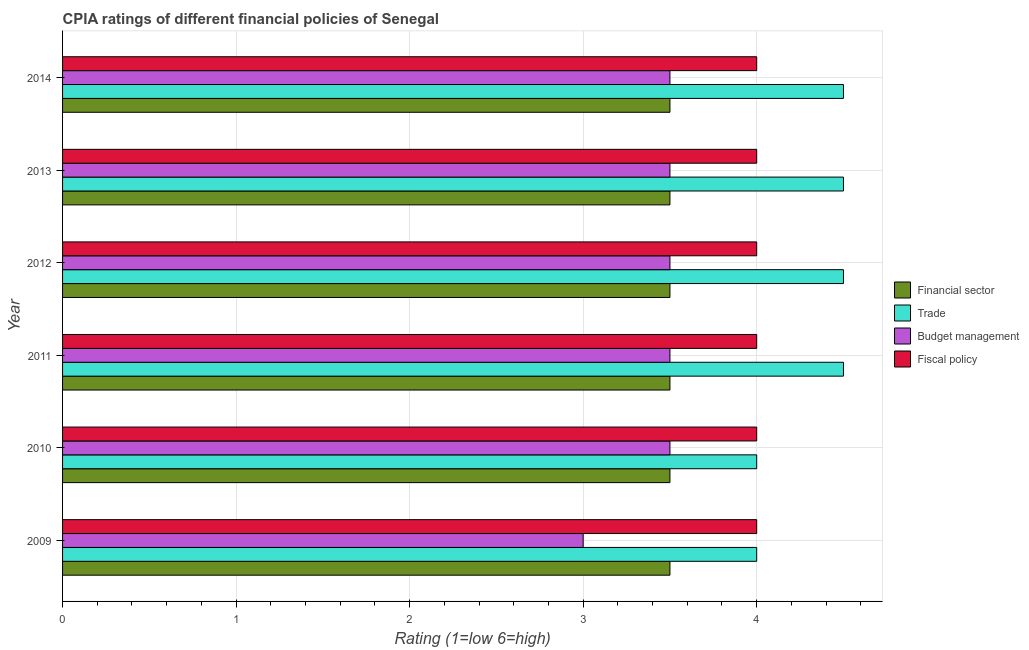How many different coloured bars are there?
Give a very brief answer. 4. How many groups of bars are there?
Your answer should be compact. 6. How many bars are there on the 5th tick from the top?
Provide a short and direct response. 4. How many bars are there on the 2nd tick from the bottom?
Your response must be concise. 4. What is the label of the 5th group of bars from the top?
Offer a very short reply. 2010. In how many cases, is the number of bars for a given year not equal to the number of legend labels?
Your answer should be very brief. 0. In which year was the cpia rating of financial sector maximum?
Make the answer very short. 2009. In which year was the cpia rating of budget management minimum?
Keep it short and to the point. 2009. What is the difference between the cpia rating of fiscal policy in 2011 and that in 2013?
Provide a succinct answer. 0. What is the difference between the cpia rating of budget management in 2012 and the cpia rating of fiscal policy in 2011?
Your answer should be compact. -0.5. What is the average cpia rating of budget management per year?
Offer a very short reply. 3.42. In the year 2011, what is the difference between the cpia rating of fiscal policy and cpia rating of budget management?
Provide a short and direct response. 0.5. What is the ratio of the cpia rating of financial sector in 2009 to that in 2013?
Provide a short and direct response. 1. Is the difference between the cpia rating of trade in 2012 and 2014 greater than the difference between the cpia rating of budget management in 2012 and 2014?
Offer a very short reply. No. What is the difference between the highest and the second highest cpia rating of trade?
Give a very brief answer. 0. Is the sum of the cpia rating of financial sector in 2011 and 2013 greater than the maximum cpia rating of trade across all years?
Give a very brief answer. Yes. What does the 3rd bar from the top in 2013 represents?
Offer a very short reply. Trade. What does the 3rd bar from the bottom in 2012 represents?
Make the answer very short. Budget management. How many bars are there?
Offer a terse response. 24. Are all the bars in the graph horizontal?
Your answer should be compact. Yes. How many years are there in the graph?
Provide a succinct answer. 6. What is the difference between two consecutive major ticks on the X-axis?
Ensure brevity in your answer.  1. Where does the legend appear in the graph?
Offer a very short reply. Center right. How are the legend labels stacked?
Keep it short and to the point. Vertical. What is the title of the graph?
Give a very brief answer. CPIA ratings of different financial policies of Senegal. Does "Primary" appear as one of the legend labels in the graph?
Give a very brief answer. No. What is the label or title of the Y-axis?
Make the answer very short. Year. What is the Rating (1=low 6=high) in Financial sector in 2009?
Your answer should be very brief. 3.5. What is the Rating (1=low 6=high) in Budget management in 2009?
Your answer should be compact. 3. What is the Rating (1=low 6=high) in Fiscal policy in 2009?
Ensure brevity in your answer.  4. What is the Rating (1=low 6=high) of Financial sector in 2010?
Offer a very short reply. 3.5. What is the Rating (1=low 6=high) of Trade in 2010?
Your answer should be compact. 4. What is the Rating (1=low 6=high) of Budget management in 2010?
Give a very brief answer. 3.5. What is the Rating (1=low 6=high) of Financial sector in 2011?
Ensure brevity in your answer.  3.5. What is the Rating (1=low 6=high) in Budget management in 2011?
Your answer should be compact. 3.5. What is the Rating (1=low 6=high) in Trade in 2012?
Provide a short and direct response. 4.5. What is the Rating (1=low 6=high) of Budget management in 2012?
Make the answer very short. 3.5. What is the Rating (1=low 6=high) in Fiscal policy in 2012?
Your answer should be very brief. 4. What is the Rating (1=low 6=high) of Trade in 2013?
Your response must be concise. 4.5. What is the Rating (1=low 6=high) in Budget management in 2013?
Offer a very short reply. 3.5. What is the Rating (1=low 6=high) of Fiscal policy in 2013?
Give a very brief answer. 4. What is the Rating (1=low 6=high) of Financial sector in 2014?
Give a very brief answer. 3.5. Across all years, what is the maximum Rating (1=low 6=high) of Financial sector?
Provide a succinct answer. 3.5. Across all years, what is the maximum Rating (1=low 6=high) of Fiscal policy?
Keep it short and to the point. 4. Across all years, what is the minimum Rating (1=low 6=high) of Trade?
Your answer should be compact. 4. Across all years, what is the minimum Rating (1=low 6=high) of Budget management?
Offer a very short reply. 3. What is the total Rating (1=low 6=high) of Fiscal policy in the graph?
Your answer should be very brief. 24. What is the difference between the Rating (1=low 6=high) in Budget management in 2009 and that in 2010?
Provide a succinct answer. -0.5. What is the difference between the Rating (1=low 6=high) of Trade in 2009 and that in 2011?
Your response must be concise. -0.5. What is the difference between the Rating (1=low 6=high) in Budget management in 2009 and that in 2011?
Give a very brief answer. -0.5. What is the difference between the Rating (1=low 6=high) in Fiscal policy in 2009 and that in 2011?
Make the answer very short. 0. What is the difference between the Rating (1=low 6=high) in Financial sector in 2009 and that in 2012?
Your response must be concise. 0. What is the difference between the Rating (1=low 6=high) in Trade in 2009 and that in 2012?
Offer a terse response. -0.5. What is the difference between the Rating (1=low 6=high) in Budget management in 2009 and that in 2012?
Keep it short and to the point. -0.5. What is the difference between the Rating (1=low 6=high) of Financial sector in 2009 and that in 2013?
Provide a succinct answer. 0. What is the difference between the Rating (1=low 6=high) of Trade in 2009 and that in 2013?
Give a very brief answer. -0.5. What is the difference between the Rating (1=low 6=high) in Budget management in 2009 and that in 2013?
Offer a very short reply. -0.5. What is the difference between the Rating (1=low 6=high) in Fiscal policy in 2009 and that in 2013?
Provide a short and direct response. 0. What is the difference between the Rating (1=low 6=high) in Financial sector in 2009 and that in 2014?
Offer a terse response. 0. What is the difference between the Rating (1=low 6=high) of Trade in 2009 and that in 2014?
Your answer should be compact. -0.5. What is the difference between the Rating (1=low 6=high) of Fiscal policy in 2009 and that in 2014?
Ensure brevity in your answer.  0. What is the difference between the Rating (1=low 6=high) of Budget management in 2010 and that in 2011?
Your answer should be compact. 0. What is the difference between the Rating (1=low 6=high) of Fiscal policy in 2010 and that in 2011?
Give a very brief answer. 0. What is the difference between the Rating (1=low 6=high) in Budget management in 2010 and that in 2012?
Your answer should be very brief. 0. What is the difference between the Rating (1=low 6=high) in Financial sector in 2010 and that in 2013?
Give a very brief answer. 0. What is the difference between the Rating (1=low 6=high) in Budget management in 2010 and that in 2013?
Provide a short and direct response. 0. What is the difference between the Rating (1=low 6=high) of Fiscal policy in 2010 and that in 2013?
Offer a very short reply. 0. What is the difference between the Rating (1=low 6=high) in Budget management in 2010 and that in 2014?
Keep it short and to the point. 0. What is the difference between the Rating (1=low 6=high) of Trade in 2011 and that in 2012?
Offer a very short reply. 0. What is the difference between the Rating (1=low 6=high) in Budget management in 2011 and that in 2012?
Offer a very short reply. 0. What is the difference between the Rating (1=low 6=high) of Trade in 2011 and that in 2013?
Make the answer very short. 0. What is the difference between the Rating (1=low 6=high) in Budget management in 2011 and that in 2013?
Provide a short and direct response. 0. What is the difference between the Rating (1=low 6=high) of Financial sector in 2011 and that in 2014?
Keep it short and to the point. 0. What is the difference between the Rating (1=low 6=high) of Trade in 2011 and that in 2014?
Keep it short and to the point. 0. What is the difference between the Rating (1=low 6=high) of Budget management in 2011 and that in 2014?
Your response must be concise. 0. What is the difference between the Rating (1=low 6=high) in Trade in 2012 and that in 2013?
Provide a short and direct response. 0. What is the difference between the Rating (1=low 6=high) of Fiscal policy in 2012 and that in 2013?
Keep it short and to the point. 0. What is the difference between the Rating (1=low 6=high) of Trade in 2012 and that in 2014?
Provide a short and direct response. 0. What is the difference between the Rating (1=low 6=high) in Fiscal policy in 2012 and that in 2014?
Offer a very short reply. 0. What is the difference between the Rating (1=low 6=high) in Financial sector in 2013 and that in 2014?
Give a very brief answer. 0. What is the difference between the Rating (1=low 6=high) in Trade in 2013 and that in 2014?
Your response must be concise. 0. What is the difference between the Rating (1=low 6=high) of Fiscal policy in 2013 and that in 2014?
Provide a short and direct response. 0. What is the difference between the Rating (1=low 6=high) of Trade in 2009 and the Rating (1=low 6=high) of Budget management in 2010?
Your answer should be very brief. 0.5. What is the difference between the Rating (1=low 6=high) of Financial sector in 2009 and the Rating (1=low 6=high) of Trade in 2011?
Offer a terse response. -1. What is the difference between the Rating (1=low 6=high) of Financial sector in 2009 and the Rating (1=low 6=high) of Budget management in 2011?
Make the answer very short. 0. What is the difference between the Rating (1=low 6=high) in Financial sector in 2009 and the Rating (1=low 6=high) in Fiscal policy in 2011?
Provide a succinct answer. -0.5. What is the difference between the Rating (1=low 6=high) of Financial sector in 2009 and the Rating (1=low 6=high) of Trade in 2012?
Make the answer very short. -1. What is the difference between the Rating (1=low 6=high) in Financial sector in 2009 and the Rating (1=low 6=high) in Budget management in 2012?
Give a very brief answer. 0. What is the difference between the Rating (1=low 6=high) in Financial sector in 2009 and the Rating (1=low 6=high) in Fiscal policy in 2012?
Your response must be concise. -0.5. What is the difference between the Rating (1=low 6=high) in Budget management in 2009 and the Rating (1=low 6=high) in Fiscal policy in 2012?
Make the answer very short. -1. What is the difference between the Rating (1=low 6=high) in Financial sector in 2009 and the Rating (1=low 6=high) in Trade in 2013?
Your answer should be very brief. -1. What is the difference between the Rating (1=low 6=high) of Financial sector in 2009 and the Rating (1=low 6=high) of Budget management in 2013?
Offer a terse response. 0. What is the difference between the Rating (1=low 6=high) in Financial sector in 2009 and the Rating (1=low 6=high) in Fiscal policy in 2013?
Ensure brevity in your answer.  -0.5. What is the difference between the Rating (1=low 6=high) of Trade in 2009 and the Rating (1=low 6=high) of Fiscal policy in 2013?
Your response must be concise. 0. What is the difference between the Rating (1=low 6=high) in Financial sector in 2009 and the Rating (1=low 6=high) in Budget management in 2014?
Your answer should be very brief. 0. What is the difference between the Rating (1=low 6=high) of Trade in 2009 and the Rating (1=low 6=high) of Fiscal policy in 2014?
Your answer should be very brief. 0. What is the difference between the Rating (1=low 6=high) in Financial sector in 2010 and the Rating (1=low 6=high) in Trade in 2011?
Your response must be concise. -1. What is the difference between the Rating (1=low 6=high) in Trade in 2010 and the Rating (1=low 6=high) in Fiscal policy in 2011?
Offer a very short reply. 0. What is the difference between the Rating (1=low 6=high) of Budget management in 2010 and the Rating (1=low 6=high) of Fiscal policy in 2011?
Offer a very short reply. -0.5. What is the difference between the Rating (1=low 6=high) of Financial sector in 2010 and the Rating (1=low 6=high) of Budget management in 2012?
Your answer should be compact. 0. What is the difference between the Rating (1=low 6=high) of Trade in 2010 and the Rating (1=low 6=high) of Fiscal policy in 2012?
Offer a very short reply. 0. What is the difference between the Rating (1=low 6=high) in Trade in 2010 and the Rating (1=low 6=high) in Budget management in 2013?
Provide a succinct answer. 0.5. What is the difference between the Rating (1=low 6=high) in Budget management in 2010 and the Rating (1=low 6=high) in Fiscal policy in 2013?
Your answer should be very brief. -0.5. What is the difference between the Rating (1=low 6=high) in Financial sector in 2010 and the Rating (1=low 6=high) in Trade in 2014?
Give a very brief answer. -1. What is the difference between the Rating (1=low 6=high) in Financial sector in 2010 and the Rating (1=low 6=high) in Budget management in 2014?
Offer a very short reply. 0. What is the difference between the Rating (1=low 6=high) in Financial sector in 2010 and the Rating (1=low 6=high) in Fiscal policy in 2014?
Your answer should be very brief. -0.5. What is the difference between the Rating (1=low 6=high) of Trade in 2010 and the Rating (1=low 6=high) of Fiscal policy in 2014?
Offer a very short reply. 0. What is the difference between the Rating (1=low 6=high) in Financial sector in 2011 and the Rating (1=low 6=high) in Trade in 2012?
Make the answer very short. -1. What is the difference between the Rating (1=low 6=high) of Financial sector in 2011 and the Rating (1=low 6=high) of Budget management in 2012?
Offer a very short reply. 0. What is the difference between the Rating (1=low 6=high) of Trade in 2011 and the Rating (1=low 6=high) of Budget management in 2012?
Keep it short and to the point. 1. What is the difference between the Rating (1=low 6=high) of Trade in 2011 and the Rating (1=low 6=high) of Fiscal policy in 2012?
Ensure brevity in your answer.  0.5. What is the difference between the Rating (1=low 6=high) of Budget management in 2011 and the Rating (1=low 6=high) of Fiscal policy in 2012?
Ensure brevity in your answer.  -0.5. What is the difference between the Rating (1=low 6=high) in Financial sector in 2011 and the Rating (1=low 6=high) in Trade in 2013?
Make the answer very short. -1. What is the difference between the Rating (1=low 6=high) in Financial sector in 2011 and the Rating (1=low 6=high) in Trade in 2014?
Provide a succinct answer. -1. What is the difference between the Rating (1=low 6=high) in Financial sector in 2011 and the Rating (1=low 6=high) in Budget management in 2014?
Your answer should be compact. 0. What is the difference between the Rating (1=low 6=high) in Trade in 2011 and the Rating (1=low 6=high) in Fiscal policy in 2014?
Your response must be concise. 0.5. What is the difference between the Rating (1=low 6=high) of Financial sector in 2012 and the Rating (1=low 6=high) of Trade in 2013?
Offer a terse response. -1. What is the difference between the Rating (1=low 6=high) of Financial sector in 2012 and the Rating (1=low 6=high) of Budget management in 2013?
Keep it short and to the point. 0. What is the difference between the Rating (1=low 6=high) in Financial sector in 2012 and the Rating (1=low 6=high) in Fiscal policy in 2013?
Make the answer very short. -0.5. What is the difference between the Rating (1=low 6=high) of Financial sector in 2012 and the Rating (1=low 6=high) of Trade in 2014?
Provide a short and direct response. -1. What is the difference between the Rating (1=low 6=high) in Trade in 2012 and the Rating (1=low 6=high) in Budget management in 2014?
Your answer should be compact. 1. What is the difference between the Rating (1=low 6=high) in Trade in 2012 and the Rating (1=low 6=high) in Fiscal policy in 2014?
Your answer should be compact. 0.5. What is the average Rating (1=low 6=high) in Trade per year?
Offer a terse response. 4.33. What is the average Rating (1=low 6=high) in Budget management per year?
Keep it short and to the point. 3.42. What is the average Rating (1=low 6=high) of Fiscal policy per year?
Your answer should be very brief. 4. In the year 2009, what is the difference between the Rating (1=low 6=high) of Financial sector and Rating (1=low 6=high) of Budget management?
Offer a terse response. 0.5. In the year 2009, what is the difference between the Rating (1=low 6=high) of Trade and Rating (1=low 6=high) of Budget management?
Ensure brevity in your answer.  1. In the year 2009, what is the difference between the Rating (1=low 6=high) of Budget management and Rating (1=low 6=high) of Fiscal policy?
Make the answer very short. -1. In the year 2010, what is the difference between the Rating (1=low 6=high) in Budget management and Rating (1=low 6=high) in Fiscal policy?
Your response must be concise. -0.5. In the year 2011, what is the difference between the Rating (1=low 6=high) of Financial sector and Rating (1=low 6=high) of Budget management?
Your response must be concise. 0. In the year 2011, what is the difference between the Rating (1=low 6=high) of Trade and Rating (1=low 6=high) of Fiscal policy?
Your response must be concise. 0.5. In the year 2012, what is the difference between the Rating (1=low 6=high) in Financial sector and Rating (1=low 6=high) in Trade?
Offer a very short reply. -1. In the year 2012, what is the difference between the Rating (1=low 6=high) of Financial sector and Rating (1=low 6=high) of Budget management?
Provide a succinct answer. 0. In the year 2012, what is the difference between the Rating (1=low 6=high) in Financial sector and Rating (1=low 6=high) in Fiscal policy?
Make the answer very short. -0.5. In the year 2012, what is the difference between the Rating (1=low 6=high) in Trade and Rating (1=low 6=high) in Budget management?
Your answer should be compact. 1. In the year 2012, what is the difference between the Rating (1=low 6=high) in Budget management and Rating (1=low 6=high) in Fiscal policy?
Ensure brevity in your answer.  -0.5. In the year 2013, what is the difference between the Rating (1=low 6=high) of Trade and Rating (1=low 6=high) of Fiscal policy?
Give a very brief answer. 0.5. In the year 2014, what is the difference between the Rating (1=low 6=high) in Financial sector and Rating (1=low 6=high) in Trade?
Your answer should be compact. -1. In the year 2014, what is the difference between the Rating (1=low 6=high) in Financial sector and Rating (1=low 6=high) in Budget management?
Give a very brief answer. 0. In the year 2014, what is the difference between the Rating (1=low 6=high) of Trade and Rating (1=low 6=high) of Fiscal policy?
Your response must be concise. 0.5. In the year 2014, what is the difference between the Rating (1=low 6=high) of Budget management and Rating (1=low 6=high) of Fiscal policy?
Offer a very short reply. -0.5. What is the ratio of the Rating (1=low 6=high) of Financial sector in 2009 to that in 2011?
Make the answer very short. 1. What is the ratio of the Rating (1=low 6=high) of Budget management in 2009 to that in 2011?
Offer a very short reply. 0.86. What is the ratio of the Rating (1=low 6=high) of Fiscal policy in 2009 to that in 2011?
Your answer should be very brief. 1. What is the ratio of the Rating (1=low 6=high) in Trade in 2009 to that in 2012?
Your response must be concise. 0.89. What is the ratio of the Rating (1=low 6=high) in Budget management in 2009 to that in 2012?
Give a very brief answer. 0.86. What is the ratio of the Rating (1=low 6=high) of Budget management in 2009 to that in 2013?
Provide a succinct answer. 0.86. What is the ratio of the Rating (1=low 6=high) in Financial sector in 2009 to that in 2014?
Your answer should be compact. 1. What is the ratio of the Rating (1=low 6=high) in Budget management in 2009 to that in 2014?
Offer a very short reply. 0.86. What is the ratio of the Rating (1=low 6=high) in Trade in 2010 to that in 2012?
Your answer should be compact. 0.89. What is the ratio of the Rating (1=low 6=high) of Budget management in 2010 to that in 2012?
Ensure brevity in your answer.  1. What is the ratio of the Rating (1=low 6=high) of Fiscal policy in 2010 to that in 2012?
Keep it short and to the point. 1. What is the ratio of the Rating (1=low 6=high) in Budget management in 2010 to that in 2013?
Ensure brevity in your answer.  1. What is the ratio of the Rating (1=low 6=high) of Trade in 2010 to that in 2014?
Your response must be concise. 0.89. What is the ratio of the Rating (1=low 6=high) in Financial sector in 2011 to that in 2012?
Keep it short and to the point. 1. What is the ratio of the Rating (1=low 6=high) of Trade in 2011 to that in 2012?
Keep it short and to the point. 1. What is the ratio of the Rating (1=low 6=high) of Budget management in 2011 to that in 2012?
Your answer should be compact. 1. What is the ratio of the Rating (1=low 6=high) in Financial sector in 2011 to that in 2013?
Your answer should be very brief. 1. What is the ratio of the Rating (1=low 6=high) of Budget management in 2011 to that in 2013?
Offer a terse response. 1. What is the ratio of the Rating (1=low 6=high) of Fiscal policy in 2011 to that in 2013?
Give a very brief answer. 1. What is the ratio of the Rating (1=low 6=high) of Financial sector in 2011 to that in 2014?
Provide a succinct answer. 1. What is the ratio of the Rating (1=low 6=high) in Trade in 2011 to that in 2014?
Make the answer very short. 1. What is the ratio of the Rating (1=low 6=high) in Financial sector in 2012 to that in 2013?
Your response must be concise. 1. What is the ratio of the Rating (1=low 6=high) in Budget management in 2012 to that in 2013?
Ensure brevity in your answer.  1. What is the ratio of the Rating (1=low 6=high) in Financial sector in 2012 to that in 2014?
Make the answer very short. 1. What is the ratio of the Rating (1=low 6=high) of Trade in 2012 to that in 2014?
Provide a short and direct response. 1. What is the ratio of the Rating (1=low 6=high) in Budget management in 2012 to that in 2014?
Offer a terse response. 1. What is the ratio of the Rating (1=low 6=high) of Fiscal policy in 2012 to that in 2014?
Ensure brevity in your answer.  1. What is the ratio of the Rating (1=low 6=high) in Financial sector in 2013 to that in 2014?
Give a very brief answer. 1. What is the ratio of the Rating (1=low 6=high) in Trade in 2013 to that in 2014?
Offer a very short reply. 1. What is the ratio of the Rating (1=low 6=high) of Fiscal policy in 2013 to that in 2014?
Provide a short and direct response. 1. What is the difference between the highest and the second highest Rating (1=low 6=high) of Trade?
Offer a terse response. 0. What is the difference between the highest and the second highest Rating (1=low 6=high) in Budget management?
Provide a succinct answer. 0. What is the difference between the highest and the lowest Rating (1=low 6=high) in Financial sector?
Your response must be concise. 0. What is the difference between the highest and the lowest Rating (1=low 6=high) of Trade?
Make the answer very short. 0.5. What is the difference between the highest and the lowest Rating (1=low 6=high) of Budget management?
Give a very brief answer. 0.5. What is the difference between the highest and the lowest Rating (1=low 6=high) in Fiscal policy?
Keep it short and to the point. 0. 